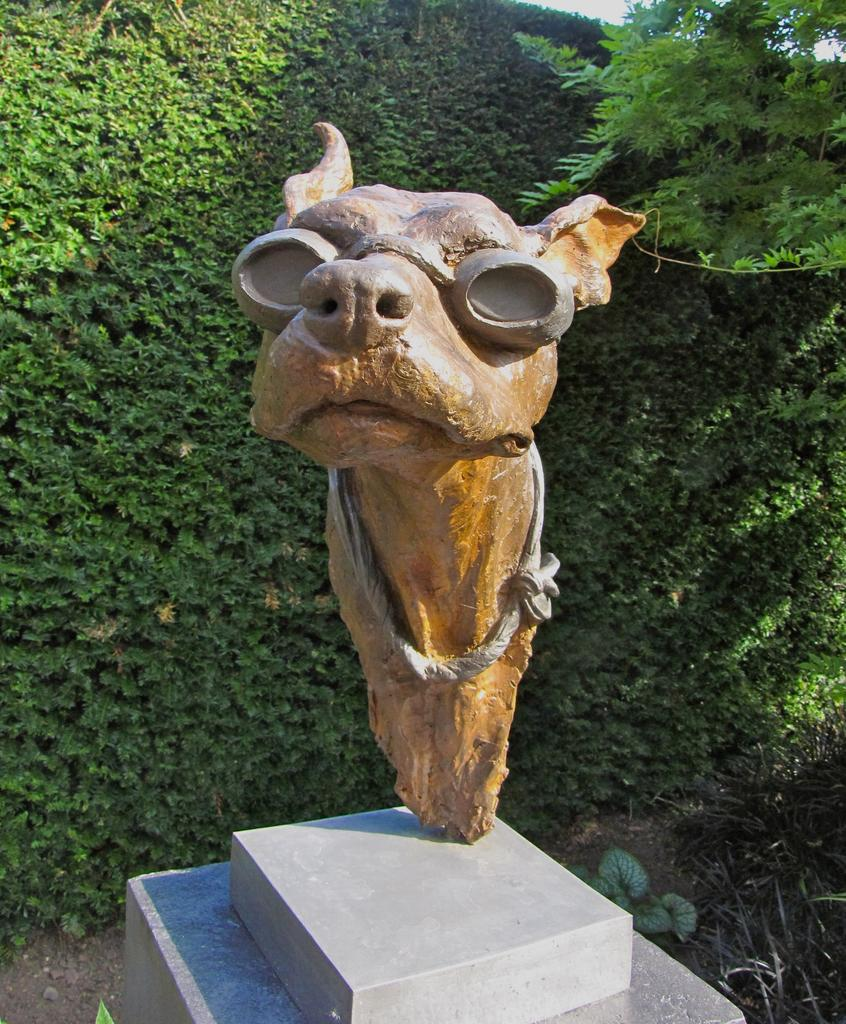What is the main subject of the image? There is a statue of an animal in the image. What color is the statue? The statue is brown in color. What can be seen in the background of the image? There are trees in the background of the image. What color are the trees? The trees are green in color. What else is visible in the image? The sky is visible in the image. What color is the sky? The sky is white in color. What type of sheet is being used for reading in the image? There is no sheet or reading activity present in the image. How is the popcorn being served in the image? There is no popcorn present in the image. 